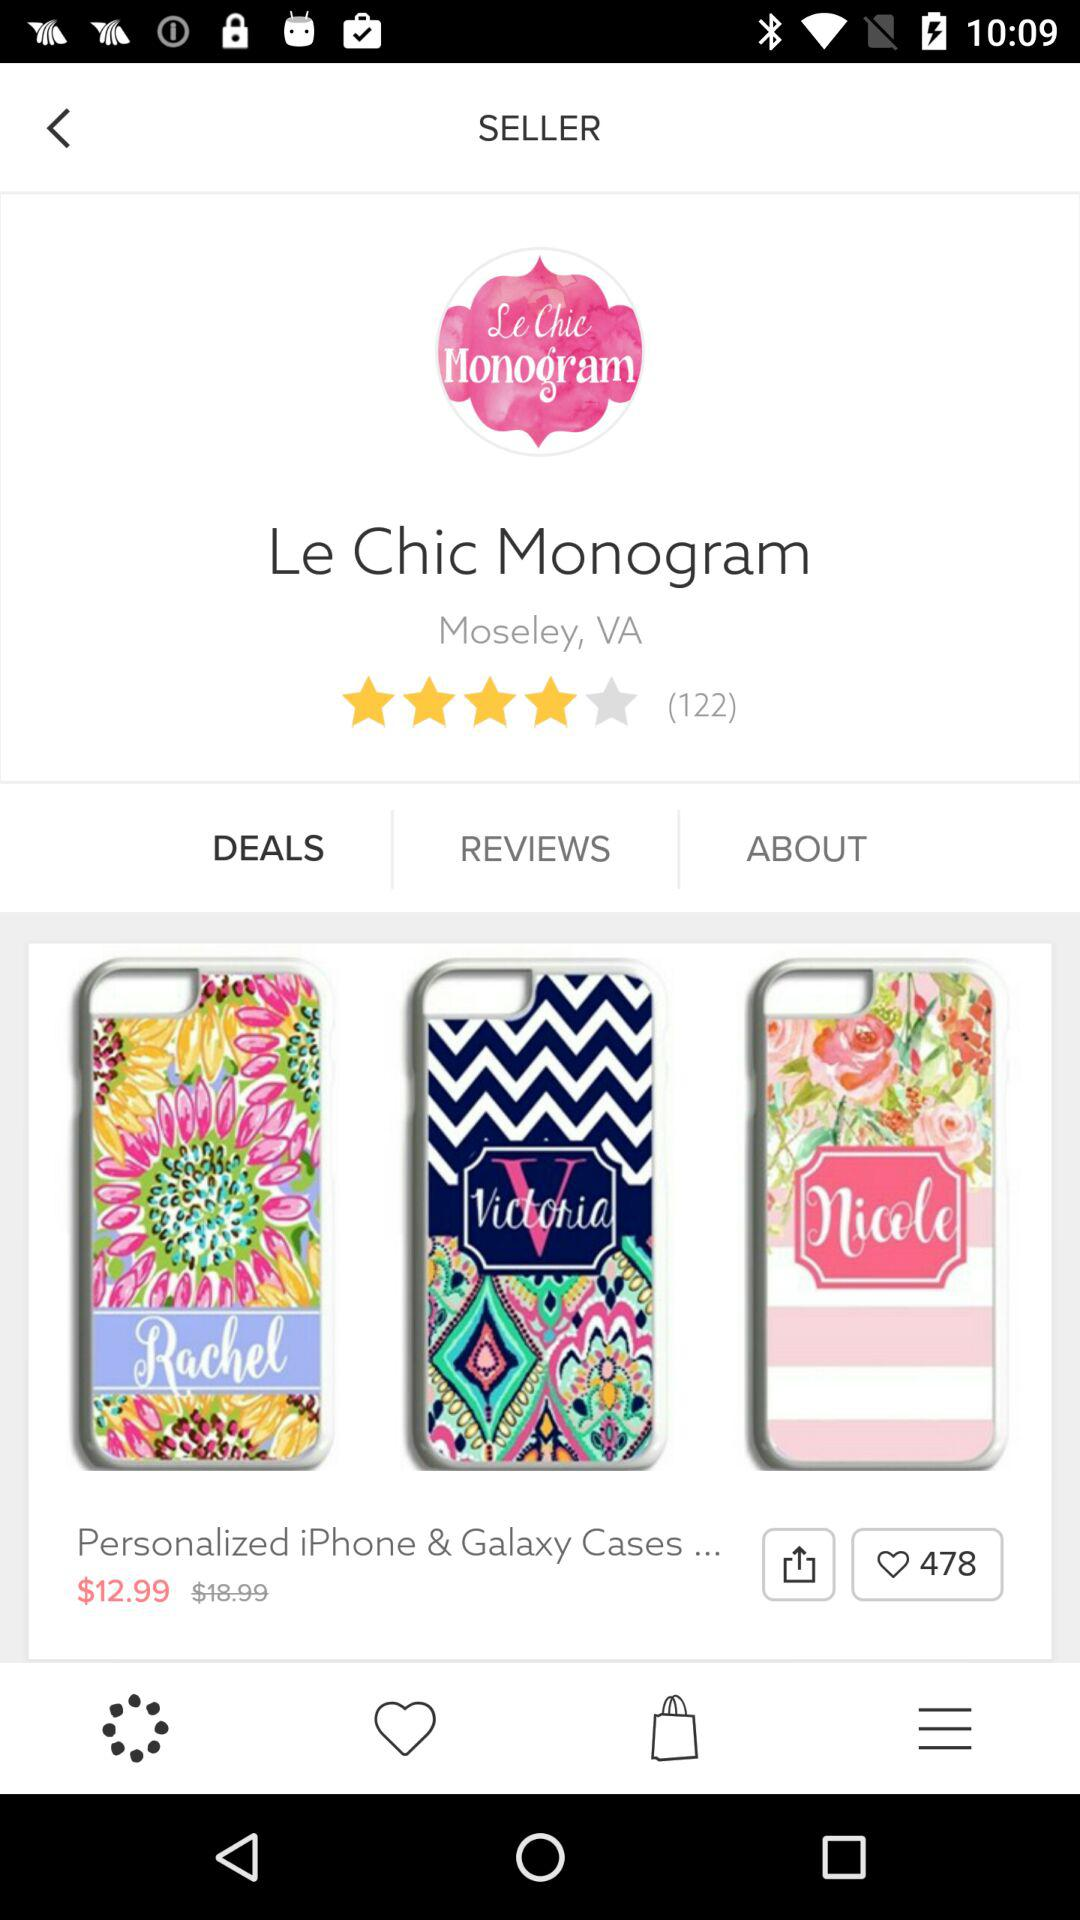How many likes are there on "Personalized iPhone & Galaxy Cases..."? There are 478 likes. 